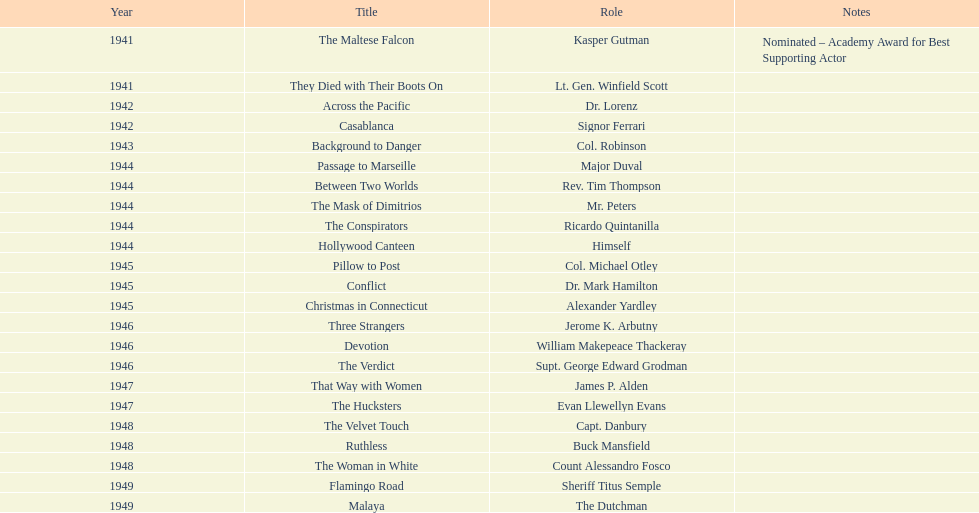Which movie did he get nominated for an oscar for? The Maltese Falcon. 